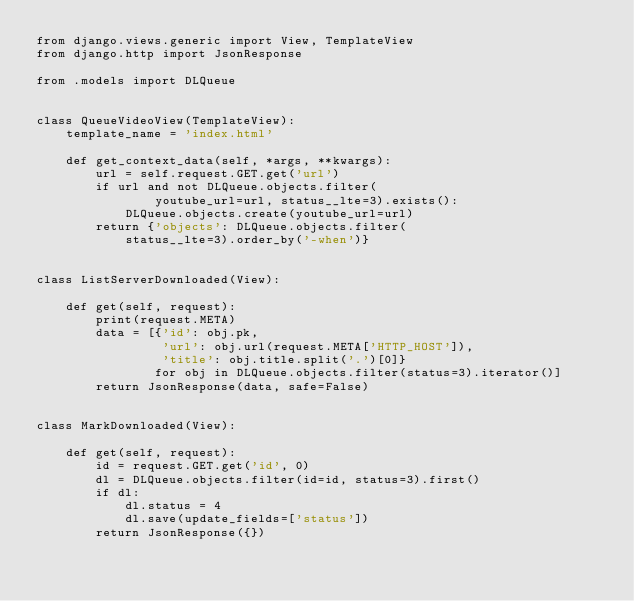<code> <loc_0><loc_0><loc_500><loc_500><_Python_>from django.views.generic import View, TemplateView
from django.http import JsonResponse

from .models import DLQueue


class QueueVideoView(TemplateView):
    template_name = 'index.html'

    def get_context_data(self, *args, **kwargs):
        url = self.request.GET.get('url')
        if url and not DLQueue.objects.filter(
                youtube_url=url, status__lte=3).exists():
            DLQueue.objects.create(youtube_url=url)
        return {'objects': DLQueue.objects.filter(
            status__lte=3).order_by('-when')}


class ListServerDownloaded(View):

    def get(self, request):
        print(request.META)
        data = [{'id': obj.pk,
                 'url': obj.url(request.META['HTTP_HOST']),
                 'title': obj.title.split('.')[0]}
                for obj in DLQueue.objects.filter(status=3).iterator()]
        return JsonResponse(data, safe=False)


class MarkDownloaded(View):

    def get(self, request):
        id = request.GET.get('id', 0)
        dl = DLQueue.objects.filter(id=id, status=3).first()
        if dl:
            dl.status = 4
            dl.save(update_fields=['status'])
        return JsonResponse({})
</code> 